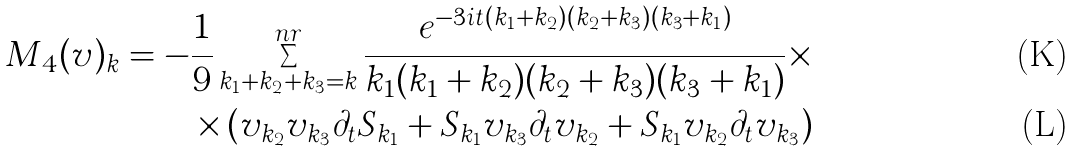Convert formula to latex. <formula><loc_0><loc_0><loc_500><loc_500>M _ { 4 } ( v ) _ { k } = - \frac { 1 } { 9 } \sum _ { k _ { 1 } + k _ { 2 } + k _ { 3 } = k } ^ { n r } \frac { e ^ { - 3 i t ( k _ { 1 } + k _ { 2 } ) ( k _ { 2 } + k _ { 3 } ) ( k _ { 3 } + k _ { 1 } ) } } { k _ { 1 } ( k _ { 1 } + k _ { 2 } ) ( k _ { 2 } + k _ { 3 } ) ( k _ { 3 } + k _ { 1 } ) } \times \\ \times \left ( v _ { k _ { 2 } } v _ { k _ { 3 } } \partial _ { t } S _ { k _ { 1 } } + S _ { k _ { 1 } } v _ { k _ { 3 } } \partial _ { t } v _ { k _ { 2 } } + S _ { k _ { 1 } } v _ { k _ { 2 } } \partial _ { t } v _ { k _ { 3 } } \right )</formula> 